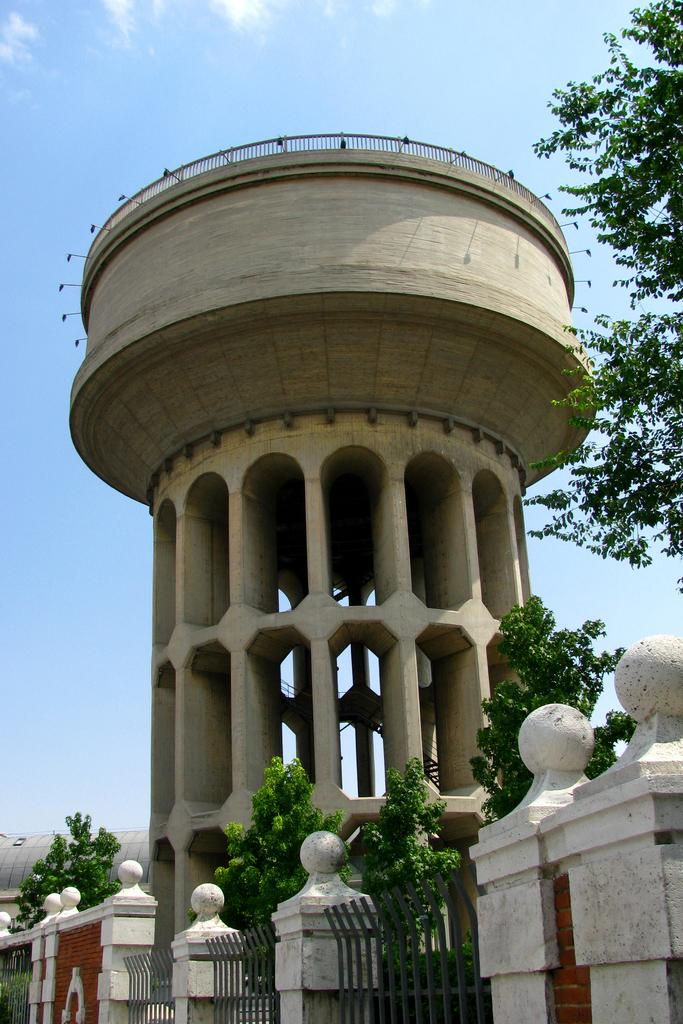What type of structures can be seen in the image? There are walls, fences, and a concrete water tank tower in the image. What natural elements are present in the image? There are trees and clouds in the sky in the image. What else can be seen in the image besides structures and natural elements? There are objects in the image. How many brothers are playing on the slope in the image? There is no slope or brothers present in the image. What type of jail can be seen in the image? There is no jail present in the image. 